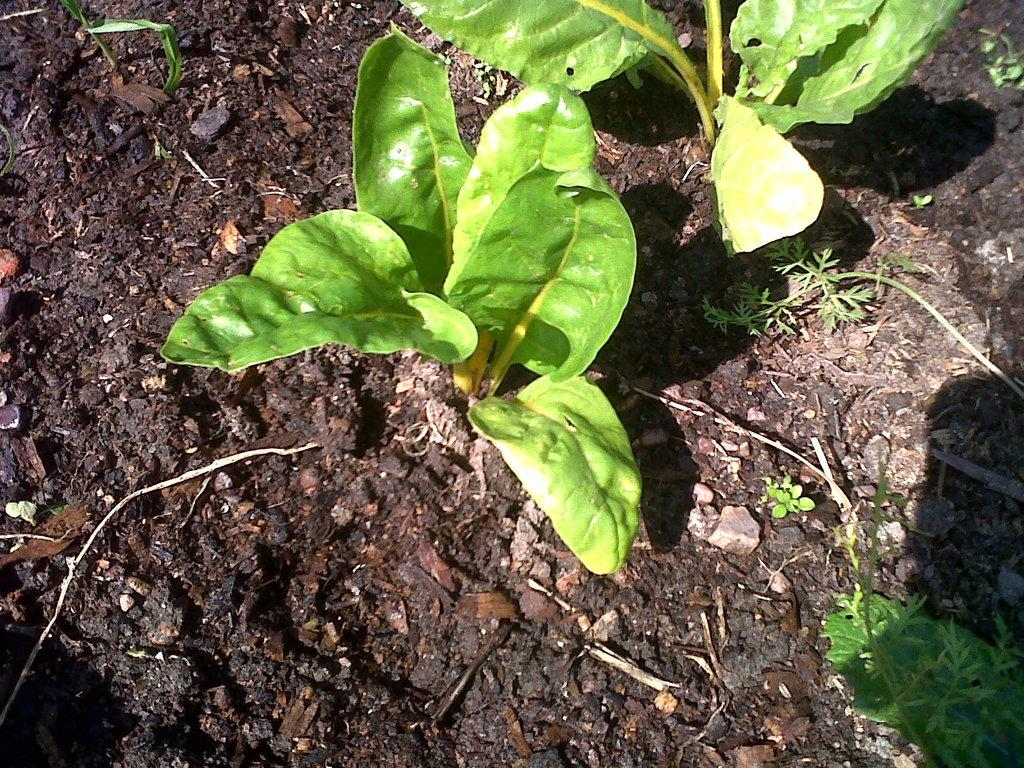What type of surface is visible in the image? There is ground visible in the image. What is present on the ground? There are plants on the ground. What colors can be seen in the plants? The plants are green and yellow in color. How many divisions are present in the person standing next to the plants in the image? There is no person present in the image, so it is not possible to determine the number of divisions in a person. 